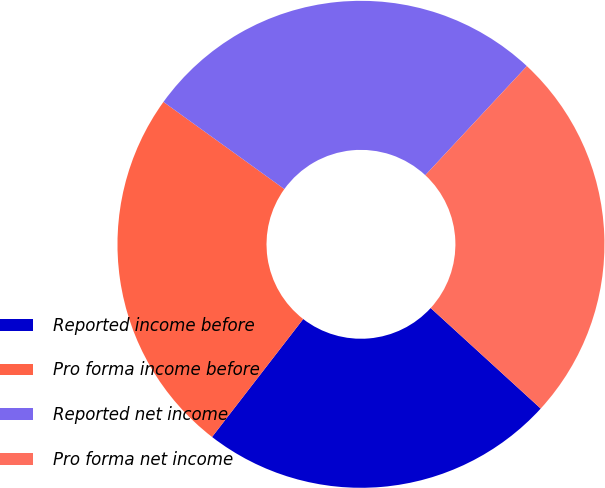<chart> <loc_0><loc_0><loc_500><loc_500><pie_chart><fcel>Reported income before<fcel>Pro forma income before<fcel>Reported net income<fcel>Pro forma net income<nl><fcel>23.69%<fcel>24.47%<fcel>26.99%<fcel>24.85%<nl></chart> 